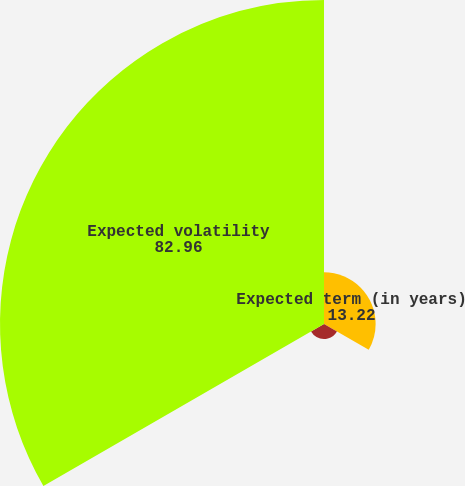<chart> <loc_0><loc_0><loc_500><loc_500><pie_chart><fcel>Expected term (in years)<fcel>Risk-free interest rate<fcel>Expected volatility<nl><fcel>13.22%<fcel>3.83%<fcel>82.96%<nl></chart> 